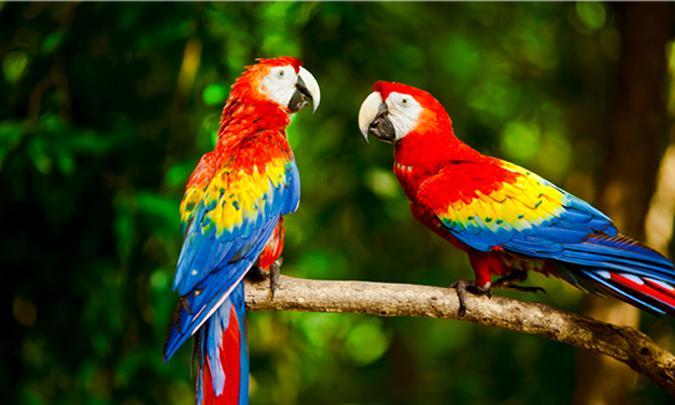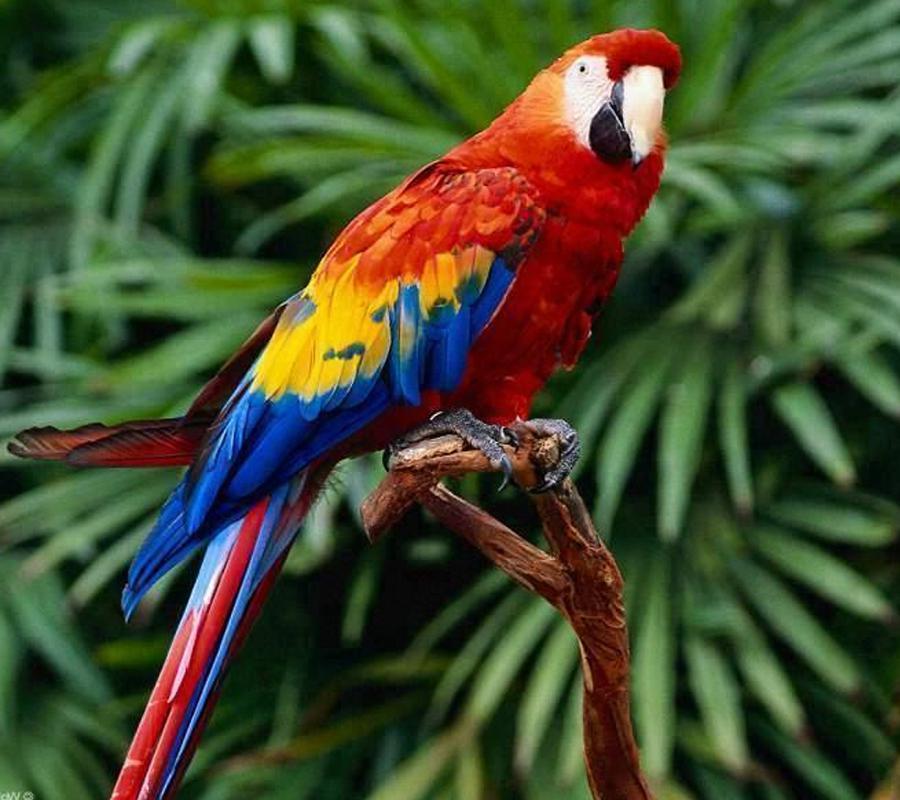The first image is the image on the left, the second image is the image on the right. Examine the images to the left and right. Is the description "At least one of the birds is flying." accurate? Answer yes or no. No. 